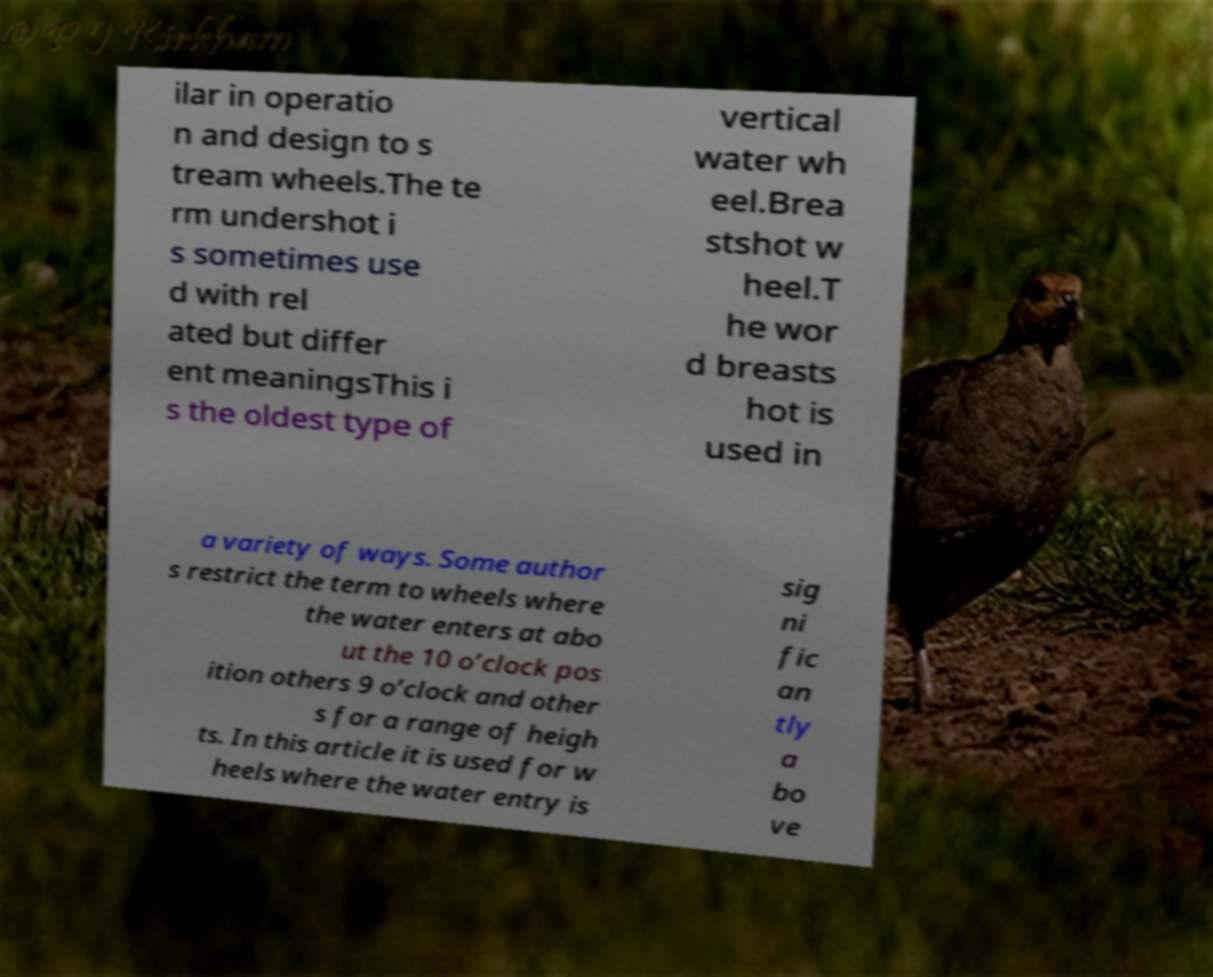Could you extract and type out the text from this image? ilar in operatio n and design to s tream wheels.The te rm undershot i s sometimes use d with rel ated but differ ent meaningsThis i s the oldest type of vertical water wh eel.Brea stshot w heel.T he wor d breasts hot is used in a variety of ways. Some author s restrict the term to wheels where the water enters at abo ut the 10 o’clock pos ition others 9 o’clock and other s for a range of heigh ts. In this article it is used for w heels where the water entry is sig ni fic an tly a bo ve 